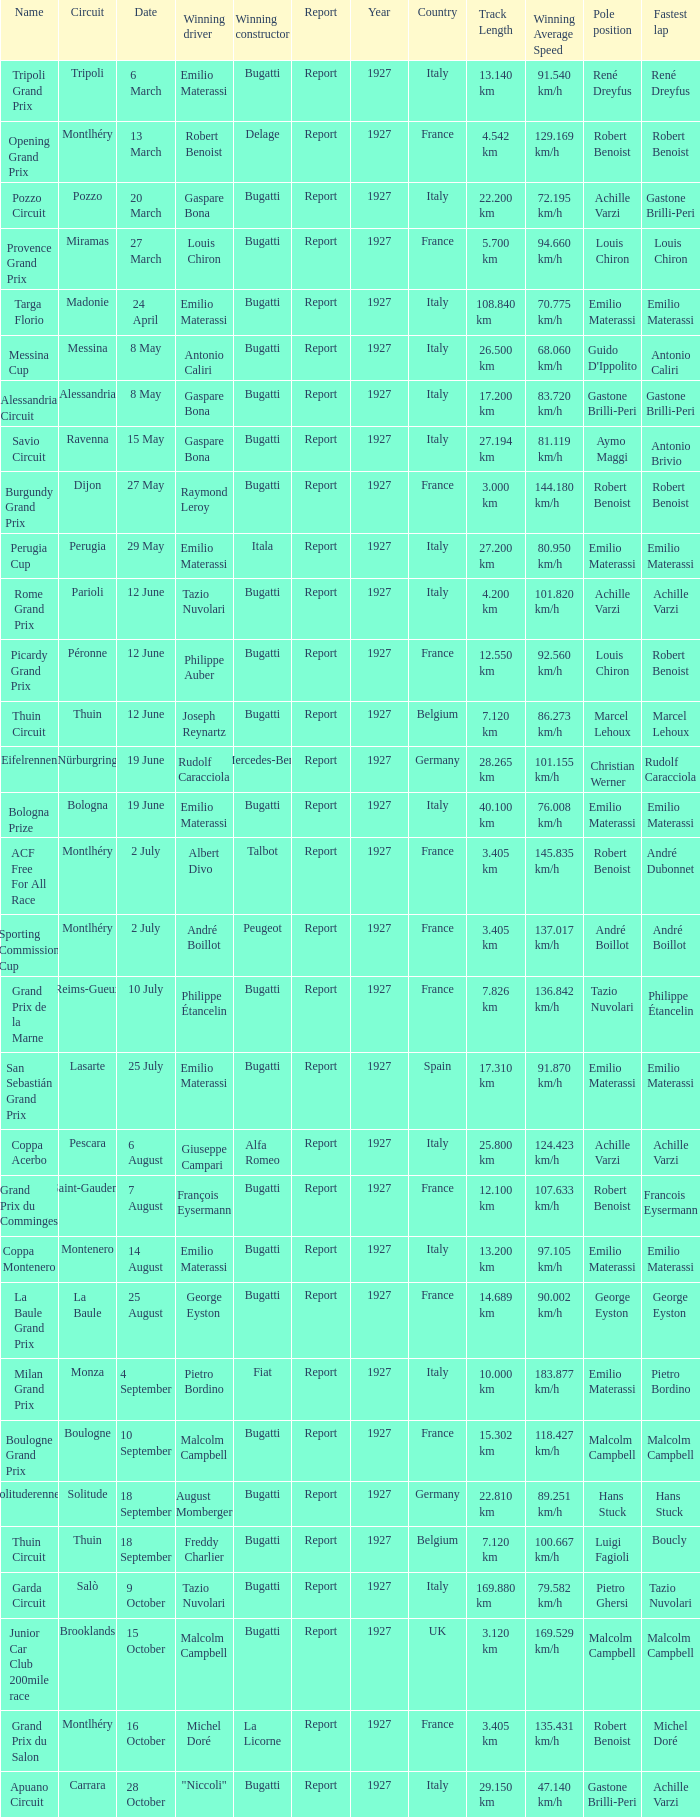When did Gaspare Bona win the Pozzo Circuit? 20 March. Can you give me this table as a dict? {'header': ['Name', 'Circuit', 'Date', 'Winning driver', 'Winning constructor', 'Report', 'Year', 'Country', 'Track Length', 'Winning Average Speed', 'Pole position', 'Fastest lap'], 'rows': [['Tripoli Grand Prix', 'Tripoli', '6 March', 'Emilio Materassi', 'Bugatti', 'Report', '1927', 'Italy', '13.140 km', '91.540 km/h', 'René Dreyfus', 'René Dreyfus'], ['Opening Grand Prix', 'Montlhéry', '13 March', 'Robert Benoist', 'Delage', 'Report', '1927', 'France', '4.542 km', '129.169 km/h', 'Robert Benoist', 'Robert Benoist'], ['Pozzo Circuit', 'Pozzo', '20 March', 'Gaspare Bona', 'Bugatti', 'Report', '1927', 'Italy', '22.200 km', '72.195 km/h', 'Achille Varzi', 'Gastone Brilli-Peri '], ['Provence Grand Prix', 'Miramas', '27 March', 'Louis Chiron', 'Bugatti', 'Report', '1927', 'France', '5.700 km', '94.660 km/h', 'Louis Chiron', 'Louis Chiron'], ['Targa Florio', 'Madonie', '24 April', 'Emilio Materassi', 'Bugatti', 'Report', '1927', 'Italy', '108.840 km', '70.775 km/h', 'Emilio Materassi', 'Emilio Materassi'], ['Messina Cup', 'Messina', '8 May', 'Antonio Caliri', 'Bugatti', 'Report', '1927', 'Italy', '26.500 km', '68.060 km/h', "Guido D'Ippolito", 'Antonio Caliri'], ['Alessandria Circuit', 'Alessandria', '8 May', 'Gaspare Bona', 'Bugatti', 'Report', '1927', 'Italy', '17.200 km', '83.720 km/h', 'Gastone Brilli-Peri', 'Gastone Brilli-Peri'], ['Savio Circuit', 'Ravenna', '15 May', 'Gaspare Bona', 'Bugatti', 'Report', '1927', 'Italy', '27.194 km', '81.119 km/h', 'Aymo Maggi', 'Antonio Brivio'], ['Burgundy Grand Prix', 'Dijon', '27 May', 'Raymond Leroy', 'Bugatti', 'Report', '1927', 'France', '3.000 km', '144.180 km/h', 'Robert Benoist', 'Robert Benoist'], ['Perugia Cup', 'Perugia', '29 May', 'Emilio Materassi', 'Itala', 'Report', '1927', 'Italy', '27.200 km', '80.950 km/h', 'Emilio Materassi', 'Emilio Materassi'], ['Rome Grand Prix', 'Parioli', '12 June', 'Tazio Nuvolari', 'Bugatti', 'Report', '1927', 'Italy', '4.200 km', '101.820 km/h', 'Achille Varzi', 'Achille Varzi '], ['Picardy Grand Prix', 'Péronne', '12 June', 'Philippe Auber', 'Bugatti', 'Report', '1927', 'France', '12.550 km', '92.560 km/h', 'Louis Chiron', 'Robert Benoist'], ['Thuin Circuit', 'Thuin', '12 June', 'Joseph Reynartz', 'Bugatti', 'Report', '1927', 'Belgium', '7.120 km', '86.273 km/h', 'Marcel Lehoux', 'Marcel Lehoux '], ['Eifelrennen', 'Nürburgring', '19 June', 'Rudolf Caracciola', 'Mercedes-Benz', 'Report', '1927', 'Germany', '28.265 km', '101.155 km/h', 'Christian Werner', 'Rudolf Caracciola'], ['Bologna Prize', 'Bologna', '19 June', 'Emilio Materassi', 'Bugatti', 'Report', '1927', 'Italy', '40.100 km', '76.008 km/h', 'Emilio Materassi', 'Emilio Materassi'], ['ACF Free For All Race', 'Montlhéry', '2 July', 'Albert Divo', 'Talbot', 'Report', '1927', 'France', '3.405 km', '145.835 km/h', 'Robert Benoist', 'André Dubonnet'], ['Sporting Commission Cup', 'Montlhéry', '2 July', 'André Boillot', 'Peugeot', 'Report', '1927', 'France', '3.405 km', '137.017 km/h', 'André Boillot', 'André Boillot '], ['Grand Prix de la Marne', 'Reims-Gueux', '10 July', 'Philippe Étancelin', 'Bugatti', 'Report', '1927', 'France', '7.826 km', '136.842 km/h', 'Tazio Nuvolari', 'Philippe Étancelin'], ['San Sebastián Grand Prix', 'Lasarte', '25 July', 'Emilio Materassi', 'Bugatti', 'Report', '1927', 'Spain', '17.310 km', '91.870 km/h', 'Emilio Materassi', 'Emilio Materassi'], ['Coppa Acerbo', 'Pescara', '6 August', 'Giuseppe Campari', 'Alfa Romeo', 'Report', '1927', 'Italy', '25.800 km', '124.423 km/h', 'Achille Varzi', 'Achille Varzi'], ['Grand Prix du Comminges', 'Saint-Gaudens', '7 August', 'François Eysermann', 'Bugatti', 'Report', '1927', 'France', '12.100 km', '107.633 km/h', 'Robert Benoist', 'Francois Eysermann'], ['Coppa Montenero', 'Montenero', '14 August', 'Emilio Materassi', 'Bugatti', 'Report', '1927', 'Italy', '13.200 km', '97.105 km/h', 'Emilio Materassi', 'Emilio Materassi '], ['La Baule Grand Prix', 'La Baule', '25 August', 'George Eyston', 'Bugatti', 'Report', '1927', 'France', '14.689 km', '90.002 km/h', 'George Eyston', 'George Eyston '], ['Milan Grand Prix', 'Monza', '4 September', 'Pietro Bordino', 'Fiat', 'Report', '1927', 'Italy', '10.000 km', '183.877 km/h', 'Emilio Materassi', 'Pietro Bordino'], ['Boulogne Grand Prix', 'Boulogne', '10 September', 'Malcolm Campbell', 'Bugatti', 'Report', '1927', 'France', '15.302 km', '118.427 km/h', 'Malcolm Campbell', 'Malcolm Campbell'], ['Solituderennen', 'Solitude', '18 September', 'August Momberger', 'Bugatti', 'Report', '1927', 'Germany', '22.810 km', '89.251 km/h', 'Hans Stuck', 'Hans Stuck '], ['Thuin Circuit', 'Thuin', '18 September', 'Freddy Charlier', 'Bugatti', 'Report', '1927', 'Belgium', '7.120 km', '100.667 km/h', 'Luigi Fagioli', 'Boucly '], ['Garda Circuit', 'Salò', '9 October', 'Tazio Nuvolari', 'Bugatti', 'Report', '1927', 'Italy', '169.880 km', '79.582 km/h', 'Pietro Ghersi', 'Tazio Nuvolari'], ['Junior Car Club 200mile race', 'Brooklands', '15 October', 'Malcolm Campbell', 'Bugatti', 'Report', '1927', 'UK', '3.120 km', '169.529 km/h', 'Malcolm Campbell', 'Malcolm Campbell'], ['Grand Prix du Salon', 'Montlhéry', '16 October', 'Michel Doré', 'La Licorne', 'Report', '1927', 'France', '3.405 km', '135.431 km/h', 'Robert Benoist', 'Michel Doré'], ['Apuano Circuit', 'Carrara', '28 October', '"Niccoli"', 'Bugatti', 'Report', '1927', 'Italy', '29.150 km', '47.140 km/h', 'Gastone Brilli-Peri', 'Achille Varzi']]} 